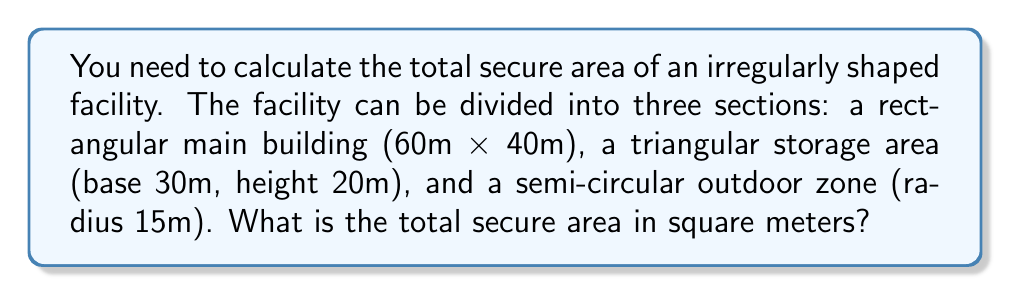Give your solution to this math problem. Let's break this down step-by-step:

1. Calculate the area of the rectangular main building:
   $$A_{rectangle} = length \times width = 60m \times 40m = 2400m^2$$

2. Calculate the area of the triangular storage area:
   $$A_{triangle} = \frac{1}{2} \times base \times height = \frac{1}{2} \times 30m \times 20m = 300m^2$$

3. Calculate the area of the semi-circular outdoor zone:
   $$A_{semicircle} = \frac{1}{2} \times \pi r^2 = \frac{1}{2} \times \pi \times (15m)^2 = \frac{1}{2} \times \pi \times 225m^2 \approx 353.43m^2$$

4. Sum up all the areas to get the total secure area:
   $$A_{total} = A_{rectangle} + A_{triangle} + A_{semicircle}$$
   $$A_{total} = 2400m^2 + 300m^2 + 353.43m^2 = 3053.43m^2$$

[asy]
import geometry;

draw((0,0)--(60,0)--(60,40)--(0,40)--cycle);
draw((60,0)--(90,0)--(75,20)--cycle);
draw(arc((90,0),15,0,180));

label("60m", (30,0), S);
label("40m", (60,20), E);
label("30m", (75,0), S);
label("20m", (82,10), E);
label("r=15m", (97,7.5), E);

dot((90,0));
[/asy]
Answer: 3053.43 m² 